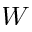<formula> <loc_0><loc_0><loc_500><loc_500>W</formula> 